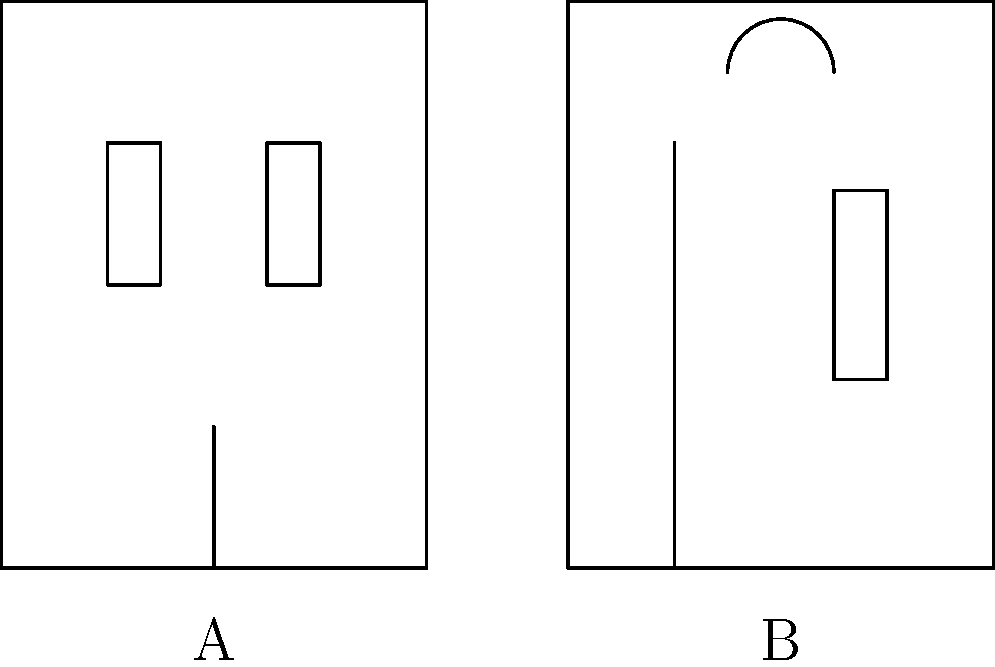Which of the architectural styles shown above (A or B) is more characteristic of the historic buildings found in downtown Mineola, particularly along Mineola Boulevard? To answer this question, we need to consider the historical development of Mineola and its architectural heritage:

1. Mineola was incorporated in 1906, but its history as a settlement dates back to the mid-19th century.

2. The Colonial Revival style (represented by Facade A) became popular in the United States from the 1880s to the 1950s. This style often features:
   - Symmetrical facade
   - Centered entrance
   - Evenly spaced windows

3. The Victorian style (represented by Facade B) was prevalent from the 1830s to the early 1900s, characterized by:
   - Asymmetrical facade
   - Decorative elements
   - Varied window sizes and shapes

4. Mineola's downtown area, particularly along Mineola Boulevard, developed significantly in the early 20th century.

5. Many of the historic buildings in downtown Mineola were constructed during the Colonial Revival period, reflecting the town's growth in the early 1900s.

6. The Mineola Memorial Library, built in 1916, is a prime example of Colonial Revival architecture in the town.

7. While there may be some Victorian-style buildings in Mineola, the Colonial Revival style is more prevalent in the downtown area, especially along Mineola Boulevard.

Therefore, based on the historical context and the prevalence of Colonial Revival architecture in Mineola's downtown area, Facade A (Colonial style) is more characteristic of the historic buildings found along Mineola Boulevard.
Answer: A (Colonial style) 